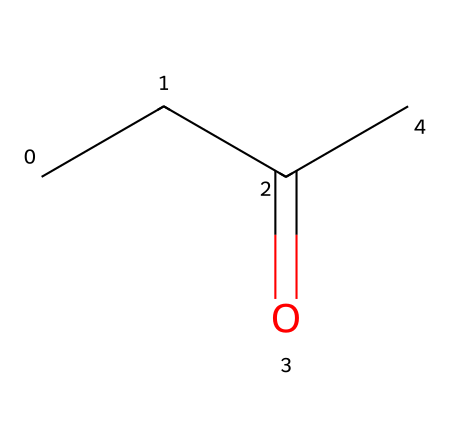What is the molecular formula of this ketone? The SMILES notation CCC(=O)C indicates there are 5 carbon atoms (C) in total, and since it's a ketone with a carbonyl group (C=O), the molecular formula can be deduced using the formula CnH2nO for ketones. Thus, for n=5, the molecular formula is C5H10O.
Answer: C5H10O How many carbon atoms are present in methyl ethyl ketone? By analyzing the SMILES, CCC(=O)C shows a total of 5 carbon atoms (three from the “CCC” and one from the carbonyl group associated with the oxygen).
Answer: 5 What functional group is present in this chemical? The compound contains a carbonyl (C=O) group, which is characteristic of ketones. This is identified from the C(=O) component in the SMILES structure, indicating the presence of a function associated with ketones.
Answer: carbonyl How many hydrogen atoms are in methyl ethyl ketone? In the SMILES representation, for the ketone C5H10O, using the standard accounting for hydrogens in organic compounds, there are 10 hydrogen atoms to maintain tetravalency of the carbon atoms, satisfying the bonding requirements.
Answer: 10 What type of molecular structure does methyl ethyl ketone represent? Methyl ethyl ketone is classified as a ketone due to the presence of a carbonyl group adjacent to other carbon atoms (not at the end of the carbon chain). The arrangement of carbon atoms indicates it's a secondary ketone because the carbonyl is bonded to two carbon groups.
Answer: ketone What is the function of the carbonyl group in ketones? The carbonyl group in ketones plays a critical role in the chemical properties and reactivity of the molecule. This group is highly polar, which enhances the solubility of ketones in water and facilitates various reactions, such as oxidation and condensation.
Answer: reactivity 